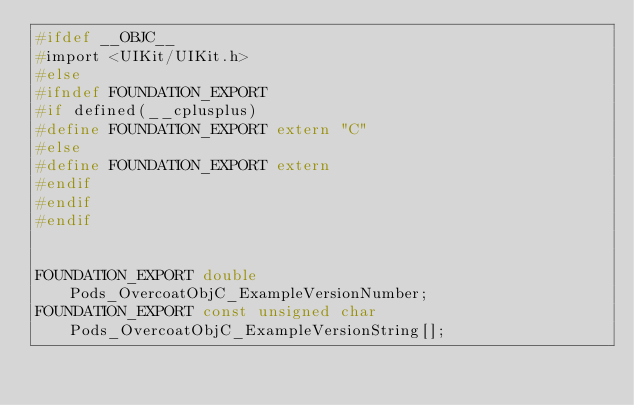Convert code to text. <code><loc_0><loc_0><loc_500><loc_500><_C_>#ifdef __OBJC__
#import <UIKit/UIKit.h>
#else
#ifndef FOUNDATION_EXPORT
#if defined(__cplusplus)
#define FOUNDATION_EXPORT extern "C"
#else
#define FOUNDATION_EXPORT extern
#endif
#endif
#endif


FOUNDATION_EXPORT double Pods_OvercoatObjC_ExampleVersionNumber;
FOUNDATION_EXPORT const unsigned char Pods_OvercoatObjC_ExampleVersionString[];

</code> 